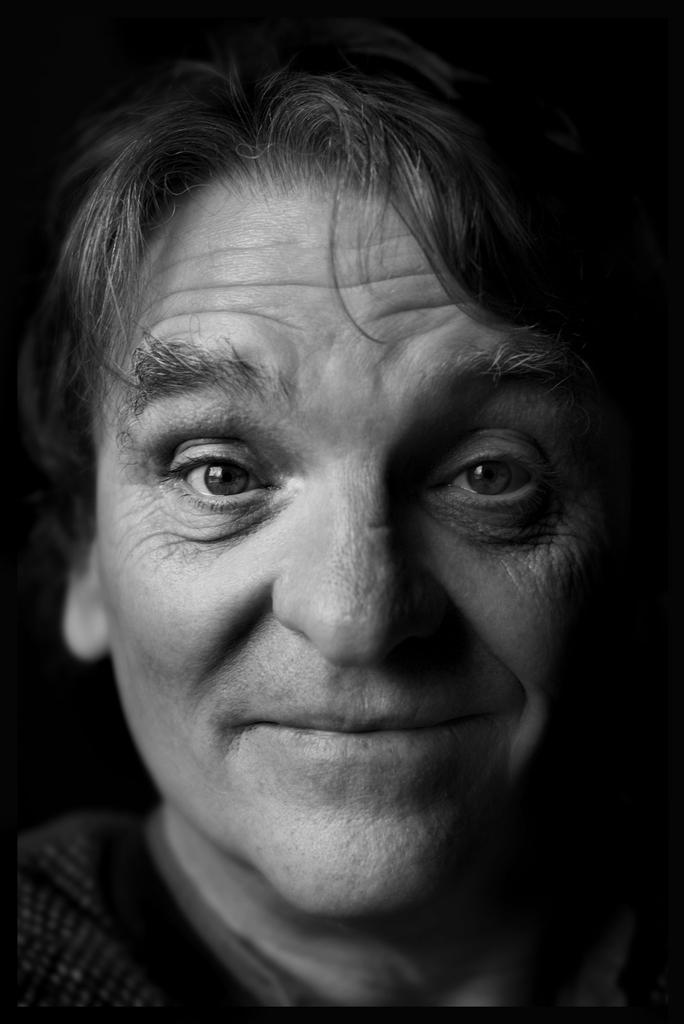What is the main subject of the image? There is a person's face in the image. What color is the background of the image? The background of the image is black. What type of behavior is the person exhibiting in the image? There is no information about the person's behavior in the image, as it only shows their face. Can you see a baseball in the image? There is no baseball present in the image. 